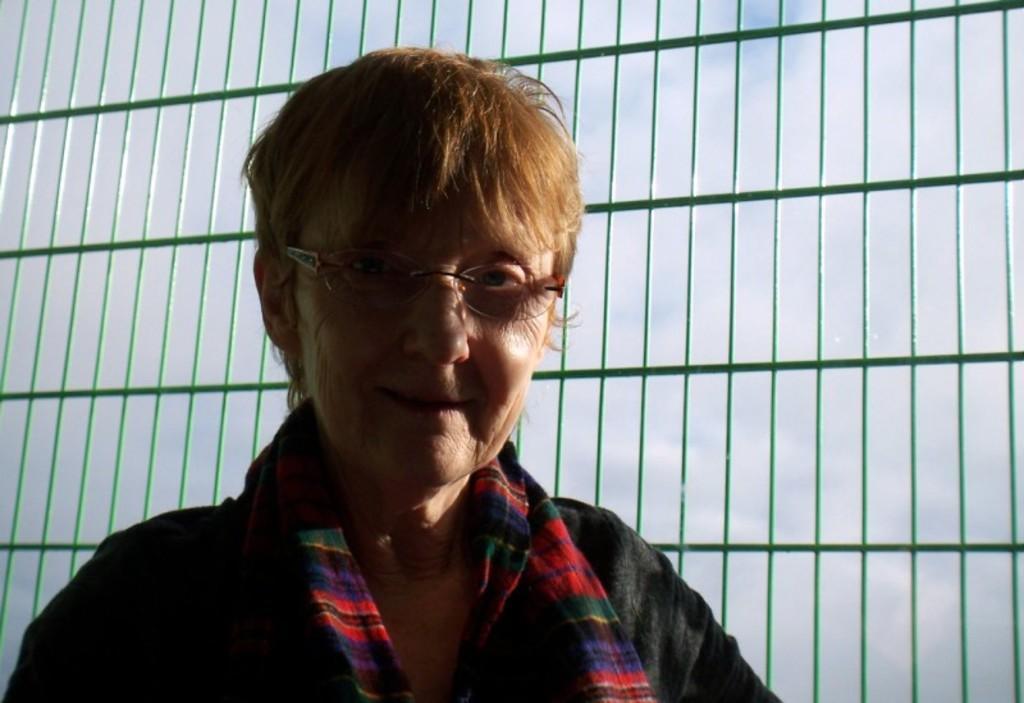Please provide a concise description of this image. In this image, we can see a person wearing clothes and spectacles in front of grills. 